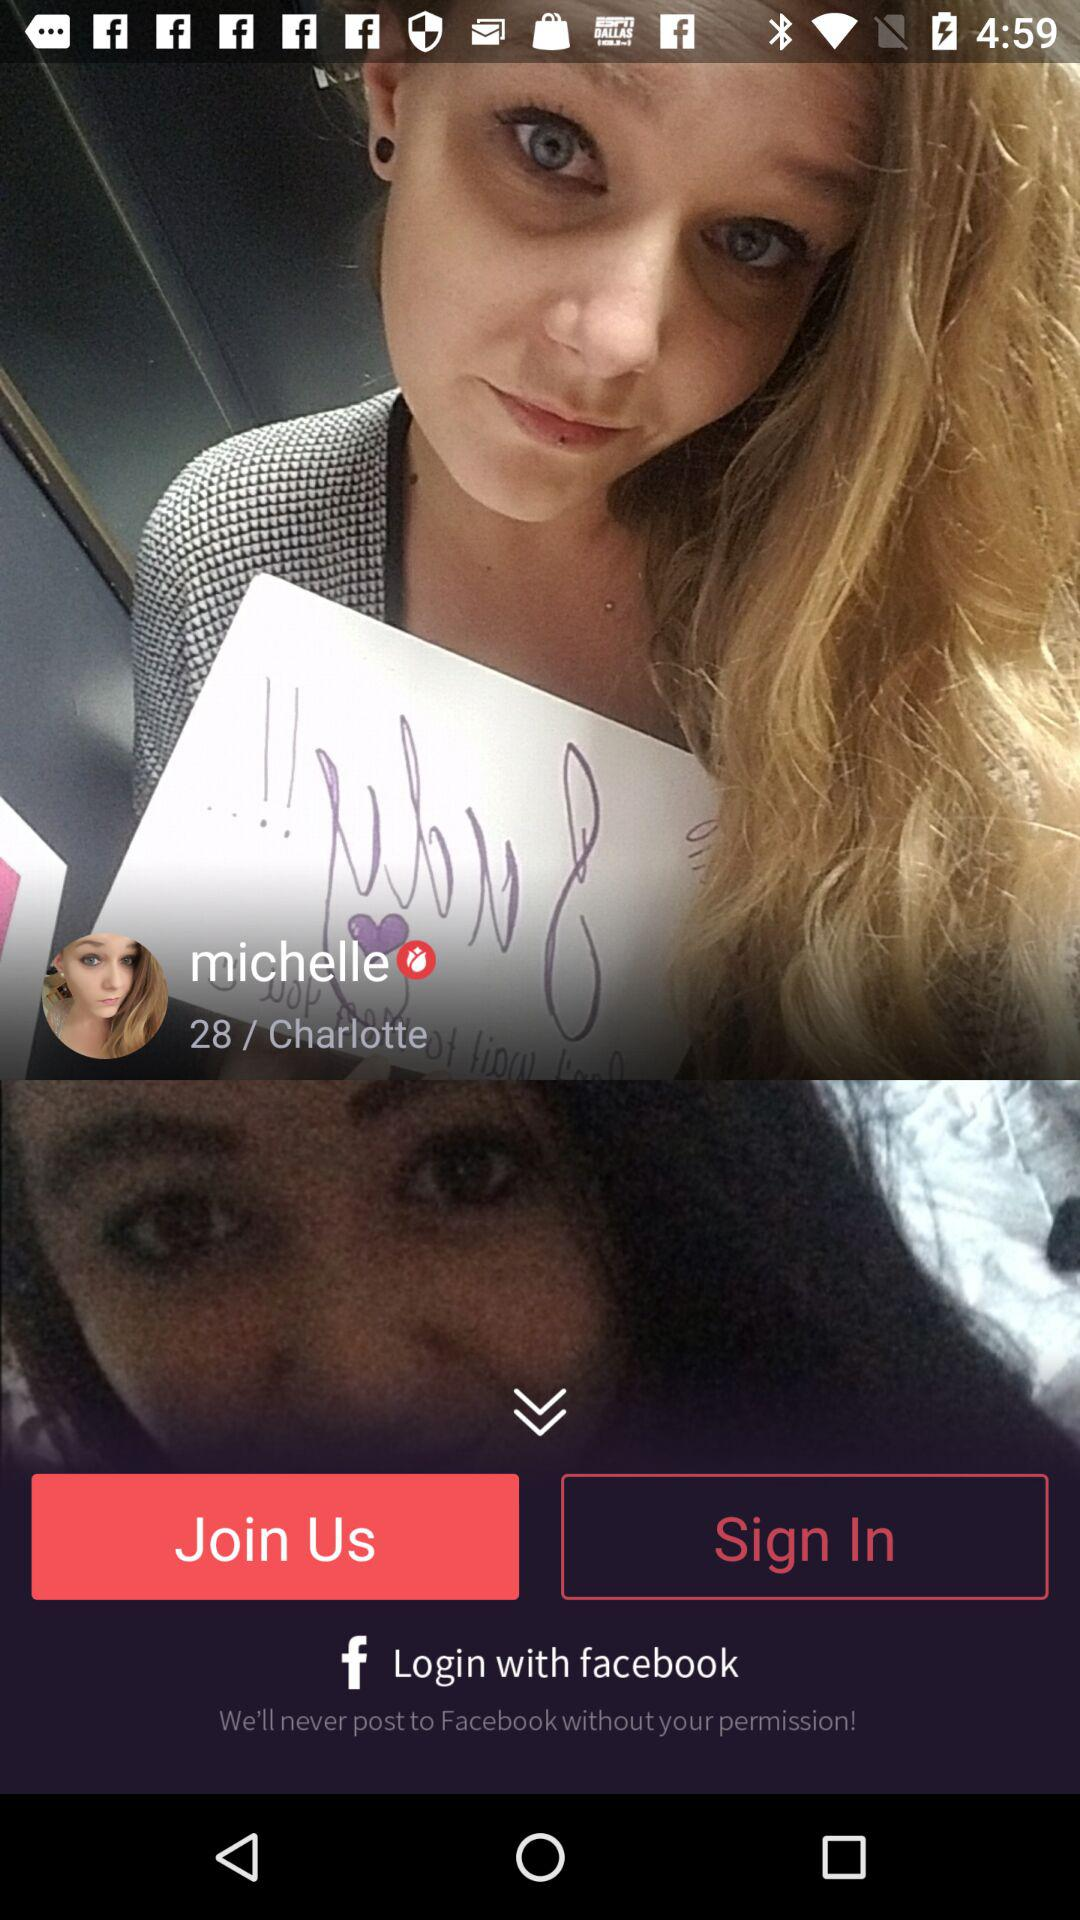How to pronounce the user name?
When the provided information is insufficient, respond with <no answer>. <no answer> 